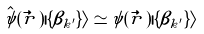<formula> <loc_0><loc_0><loc_500><loc_500>\hat { \psi } ( \vec { r } \, ) | \{ \beta _ { k ^ { \prime } } \} \rangle \simeq \psi ( \vec { r } \, ) | \{ \beta _ { k ^ { \prime } } \} \rangle</formula> 